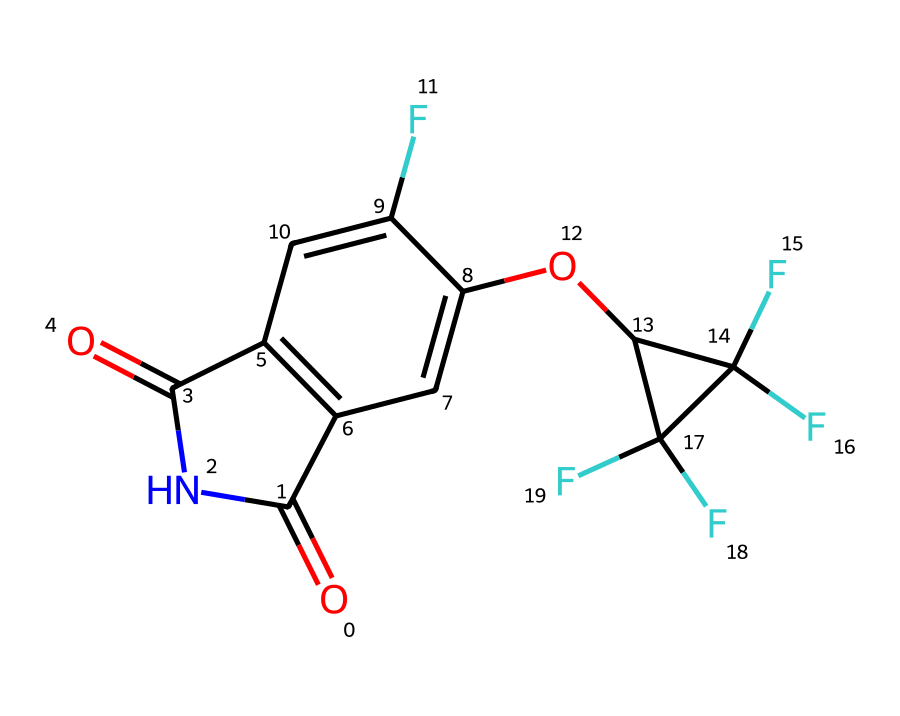What is the name of this chemical? The chemical is identified through its structural formula and is known as fludioxonil, a fungicide commonly used in agriculture.
Answer: fludioxonil How many fluorine atoms are present in this structure? By analyzing the structural formula, we see there are three distinct fluorine (F) atoms in the structure, indicated by the ‘F’ symbols attached to the carbon atoms.
Answer: three What is the molecular formula of fludioxonil? To determine the molecular formula, count the elements represented in the SMILES: C (carbon), H (hydrogen), F (fluorine), N (nitrogen), and O (oxygen). The complete count leads to the formula C14H12F3N3O3.
Answer: C14H12F3N3O3 What type of bond connects the carbon atoms in this molecule? The carbon atoms in fludioxonil are primarily connected by single (sigma) bonds and few double bonds, which are typically represented between the carbon and oxygen in functional groups.
Answer: single and double bonds How many rings are present in the structure? The analysis of the structural representation shows there are two distinct rings: an aromatic system and another heterocyclic structure due to the presence of nitrogen.
Answer: two What major functional groups are present in fludioxonil? The key functional groups identified in the structure include carbonyl (C=O) and an amide group (N-C=O), which are essential in determining its chemical properties and function as a fungicide.
Answer: carbonyl and amide What is the primary application of fludioxonil? Fludioxonil is primarily used as a fungicide to control diseases in crops and ornamental plants, including flowers at events like music festivals, ensuring their health and aesthetic appeal.
Answer: fungicide 